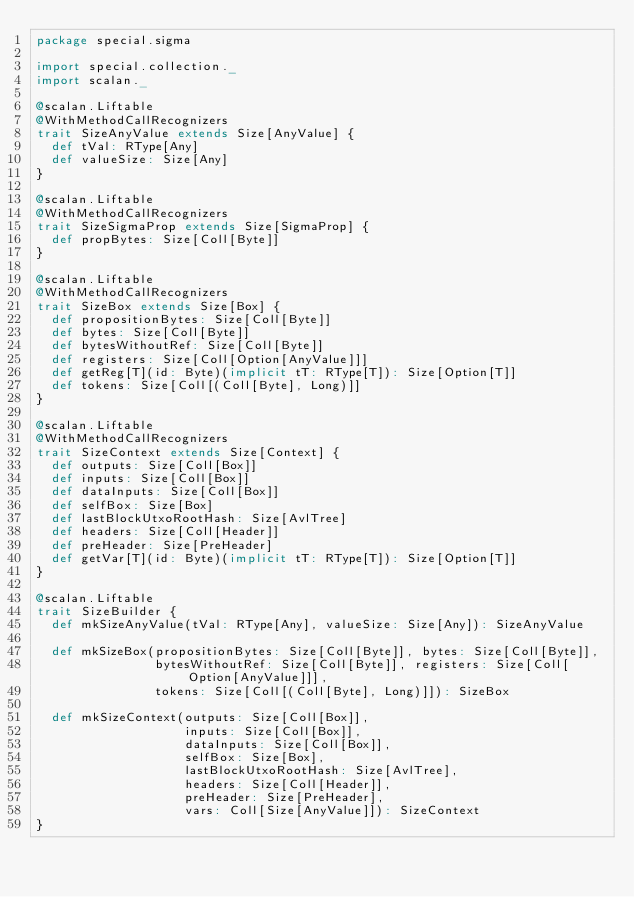Convert code to text. <code><loc_0><loc_0><loc_500><loc_500><_Scala_>package special.sigma

import special.collection._
import scalan._

@scalan.Liftable
@WithMethodCallRecognizers
trait SizeAnyValue extends Size[AnyValue] {
  def tVal: RType[Any]
  def valueSize: Size[Any]
}

@scalan.Liftable
@WithMethodCallRecognizers
trait SizeSigmaProp extends Size[SigmaProp] {
  def propBytes: Size[Coll[Byte]]
}

@scalan.Liftable
@WithMethodCallRecognizers
trait SizeBox extends Size[Box] {
  def propositionBytes: Size[Coll[Byte]]
  def bytes: Size[Coll[Byte]]
  def bytesWithoutRef: Size[Coll[Byte]]
  def registers: Size[Coll[Option[AnyValue]]]
  def getReg[T](id: Byte)(implicit tT: RType[T]): Size[Option[T]]
  def tokens: Size[Coll[(Coll[Byte], Long)]]
}

@scalan.Liftable
@WithMethodCallRecognizers
trait SizeContext extends Size[Context] {
  def outputs: Size[Coll[Box]]
  def inputs: Size[Coll[Box]]
  def dataInputs: Size[Coll[Box]]
  def selfBox: Size[Box]
  def lastBlockUtxoRootHash: Size[AvlTree]
  def headers: Size[Coll[Header]]
  def preHeader: Size[PreHeader]
  def getVar[T](id: Byte)(implicit tT: RType[T]): Size[Option[T]]
}

@scalan.Liftable
trait SizeBuilder {
  def mkSizeAnyValue(tVal: RType[Any], valueSize: Size[Any]): SizeAnyValue

  def mkSizeBox(propositionBytes: Size[Coll[Byte]], bytes: Size[Coll[Byte]],
                bytesWithoutRef: Size[Coll[Byte]], registers: Size[Coll[Option[AnyValue]]],
                tokens: Size[Coll[(Coll[Byte], Long)]]): SizeBox

  def mkSizeContext(outputs: Size[Coll[Box]],
                    inputs: Size[Coll[Box]],
                    dataInputs: Size[Coll[Box]],
                    selfBox: Size[Box],
                    lastBlockUtxoRootHash: Size[AvlTree],
                    headers: Size[Coll[Header]],
                    preHeader: Size[PreHeader],
                    vars: Coll[Size[AnyValue]]): SizeContext
}


</code> 